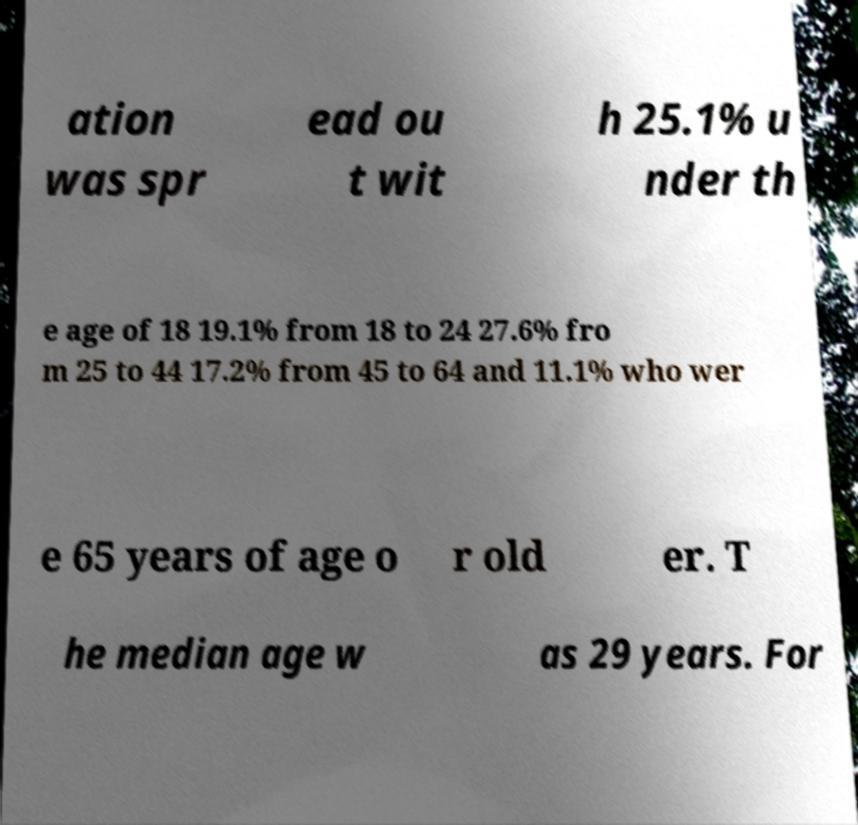Please read and relay the text visible in this image. What does it say? ation was spr ead ou t wit h 25.1% u nder th e age of 18 19.1% from 18 to 24 27.6% fro m 25 to 44 17.2% from 45 to 64 and 11.1% who wer e 65 years of age o r old er. T he median age w as 29 years. For 